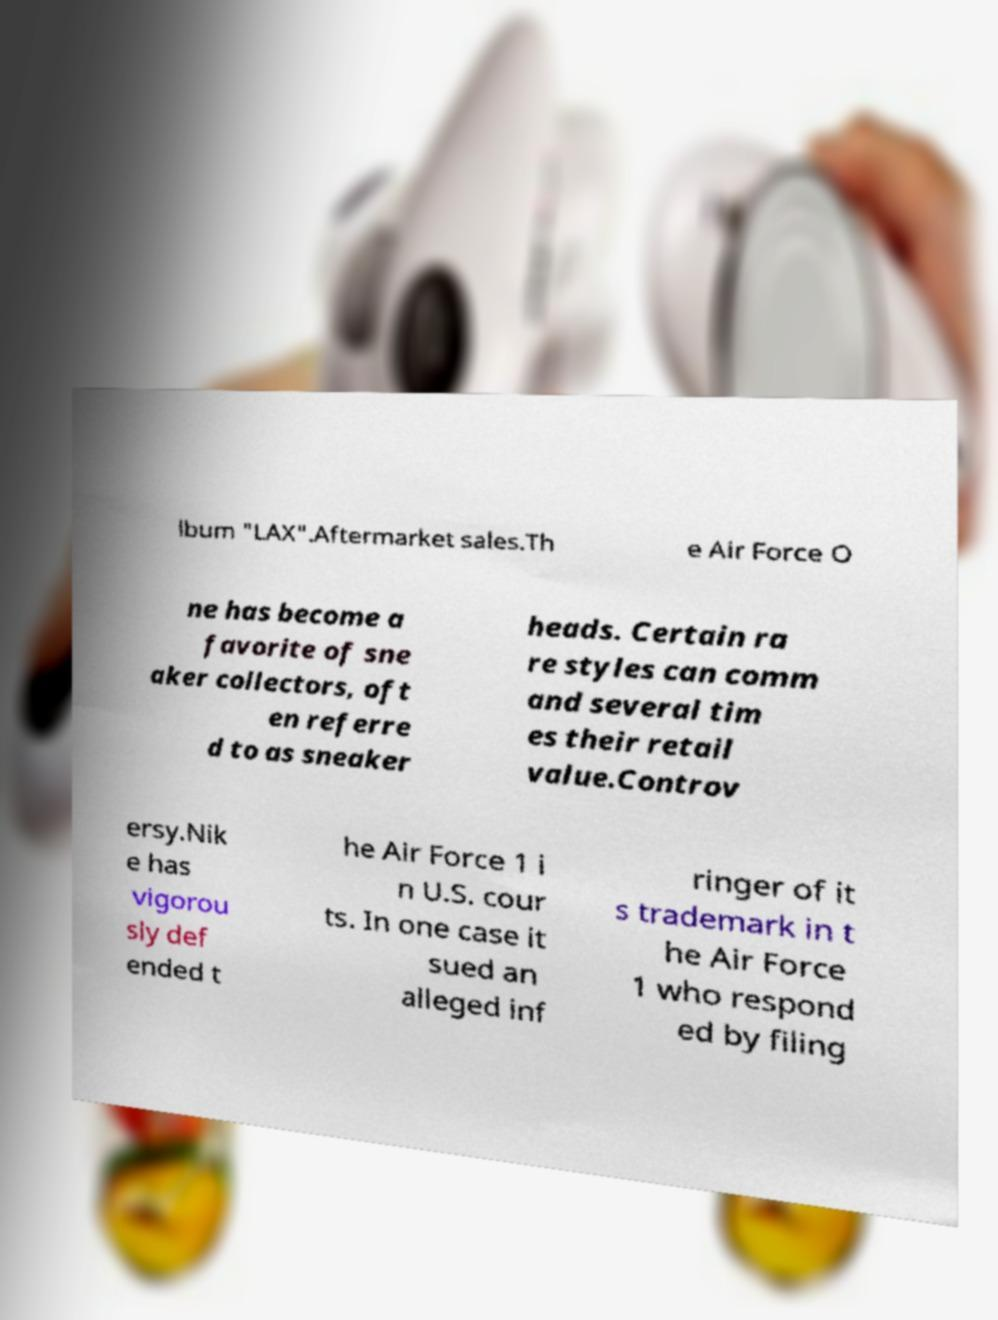Could you assist in decoding the text presented in this image and type it out clearly? lbum "LAX".Aftermarket sales.Th e Air Force O ne has become a favorite of sne aker collectors, oft en referre d to as sneaker heads. Certain ra re styles can comm and several tim es their retail value.Controv ersy.Nik e has vigorou sly def ended t he Air Force 1 i n U.S. cour ts. In one case it sued an alleged inf ringer of it s trademark in t he Air Force 1 who respond ed by filing 